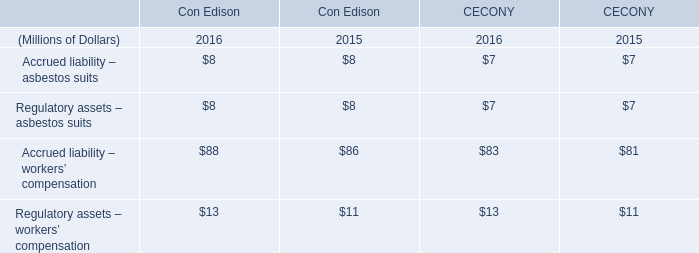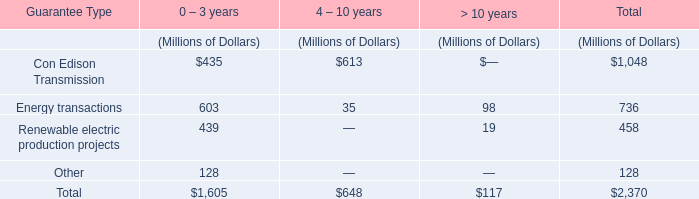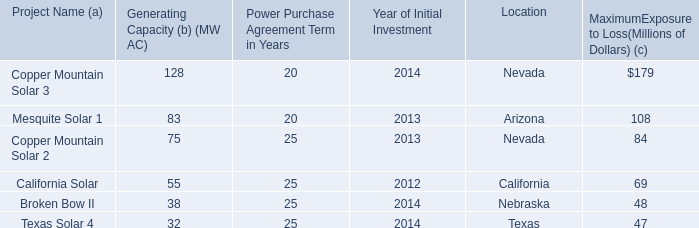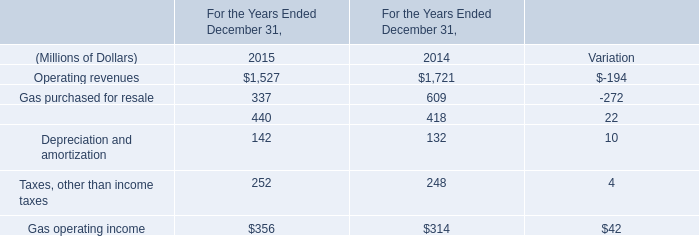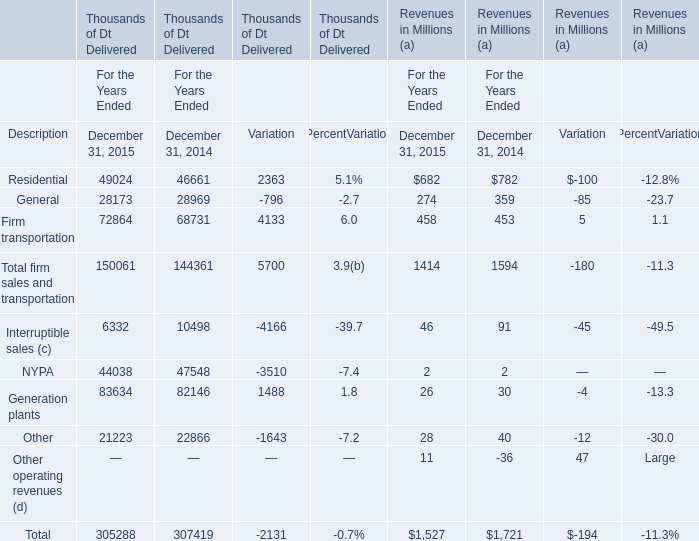In the year with the most Operating revenues, what is the growth rate of 2015? 
Computations: (-194 / 1527)
Answer: -0.12705. 